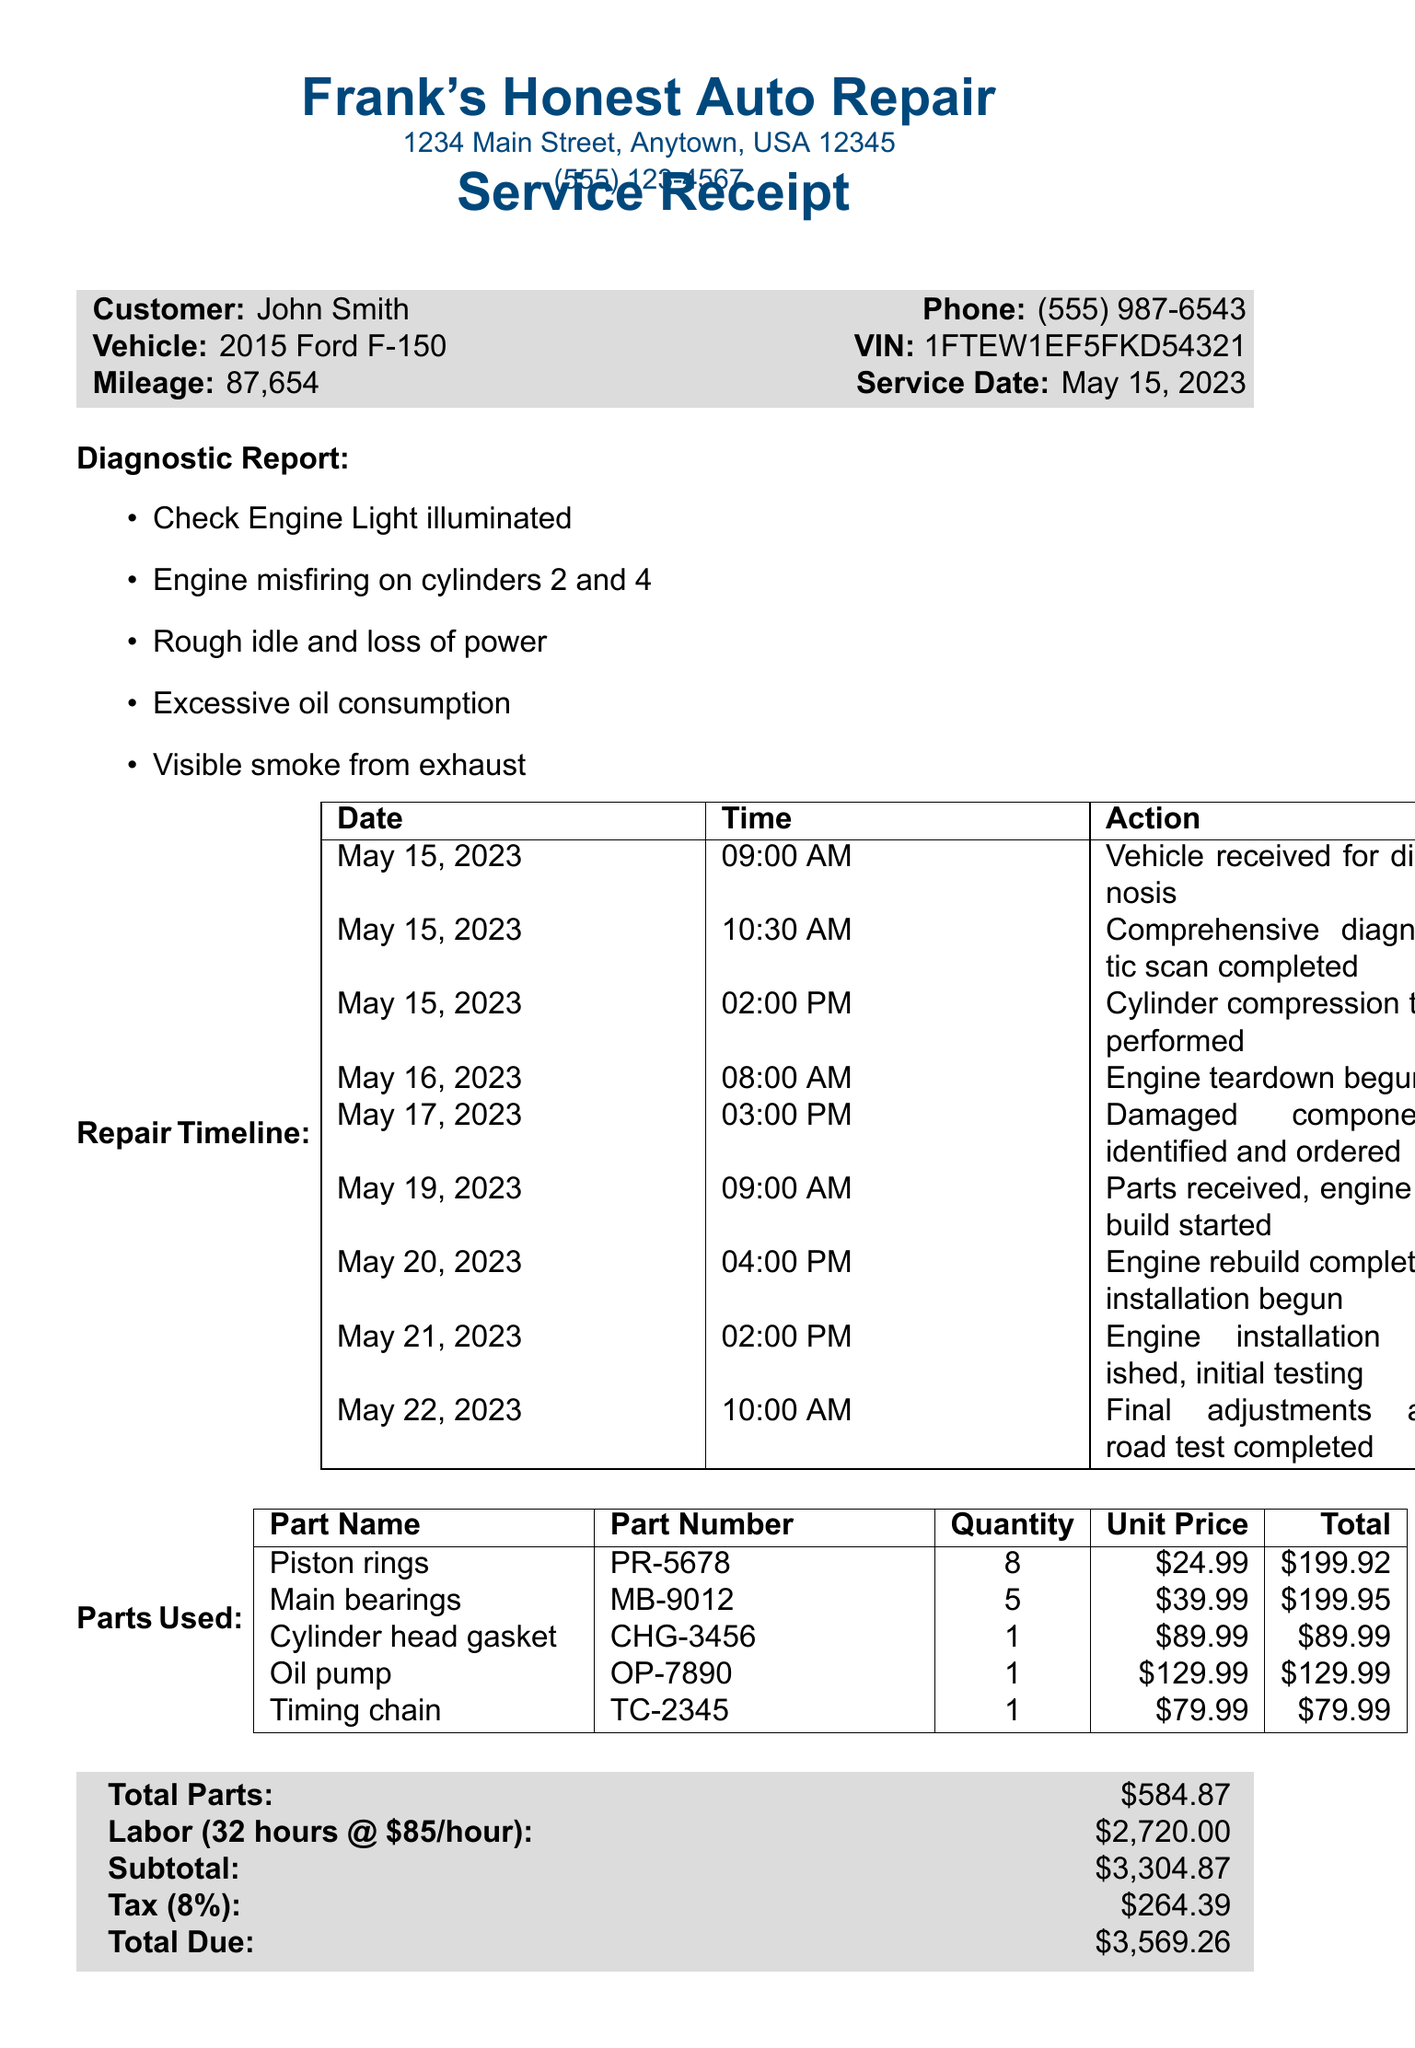What is the shop name? The shop name is mentioned in the header of the document.
Answer: Frank's Honest Auto Repair Who is the mechanic? The mechanic's name is noted at the bottom of the document near the signature.
Answer: Frank Johnson What is the service date? The service date is provided in the customer information section of the document.
Answer: May 15, 2023 What is the total due amount? The total due amount is found in the summary of charges at the end of the document.
Answer: $3,569.26 How many labor hours were billed? The labor hours are stated in the pricing summary section of the document.
Answer: 32 What parts were ordered on May 17, 2023? This action is detailed in the repair timeline, which lists actions taken on specific dates.
Answer: Damaged components identified and ordered What type of warranty is provided? The warranty information is mentioned toward the end of the document.
Answer: 90-day warranty on parts and labor Which component had 8 units ordered? The parts used section lists the number of units for each part.
Answer: Piston rings 